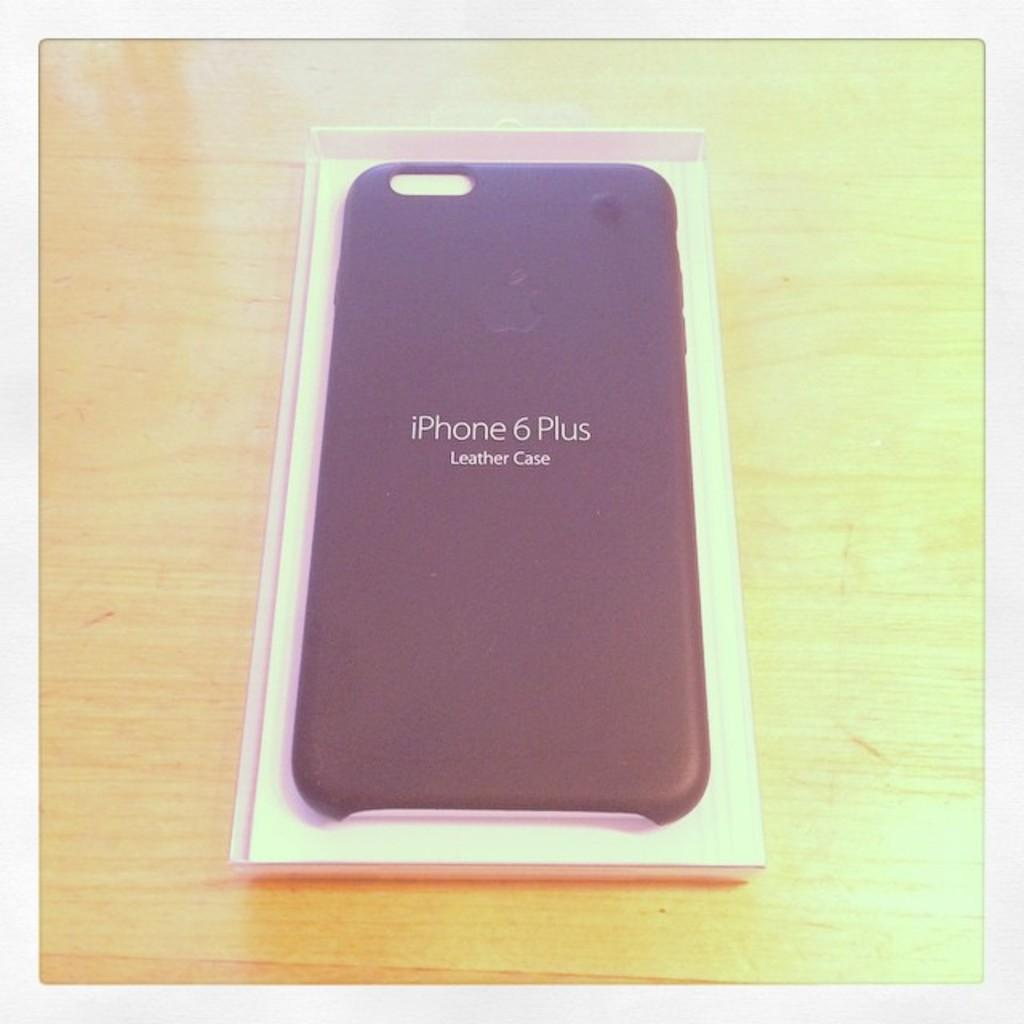<image>
Relay a brief, clear account of the picture shown. a black iphone 6 plus leather case in a white box 